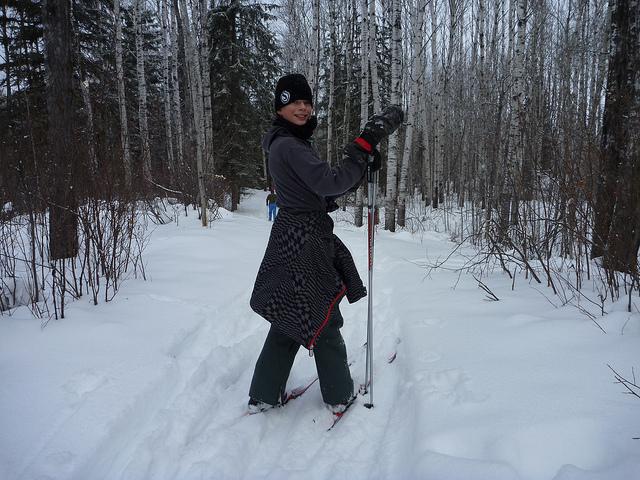What number of branches are surrounding the road?
Give a very brief answer. Lot. What is tied around their waist?
Be succinct. Jacket. What color is the person's hat?
Concise answer only. Black. What is the person doing?
Write a very short answer. Skiing. Is it a man or woman in the picture?
Answer briefly. Woman. Was the man standing still when this picture was taken?
Quick response, please. Yes. 